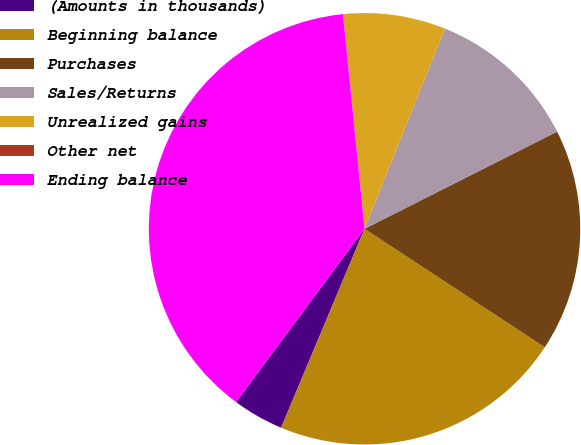Convert chart. <chart><loc_0><loc_0><loc_500><loc_500><pie_chart><fcel>(Amounts in thousands)<fcel>Beginning balance<fcel>Purchases<fcel>Sales/Returns<fcel>Unrealized gains<fcel>Other net<fcel>Ending balance<nl><fcel>3.84%<fcel>22.06%<fcel>16.69%<fcel>11.48%<fcel>7.66%<fcel>0.02%<fcel>38.24%<nl></chart> 